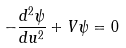<formula> <loc_0><loc_0><loc_500><loc_500>- \frac { d ^ { 2 } \psi } { d u ^ { 2 } } + V \psi = 0</formula> 